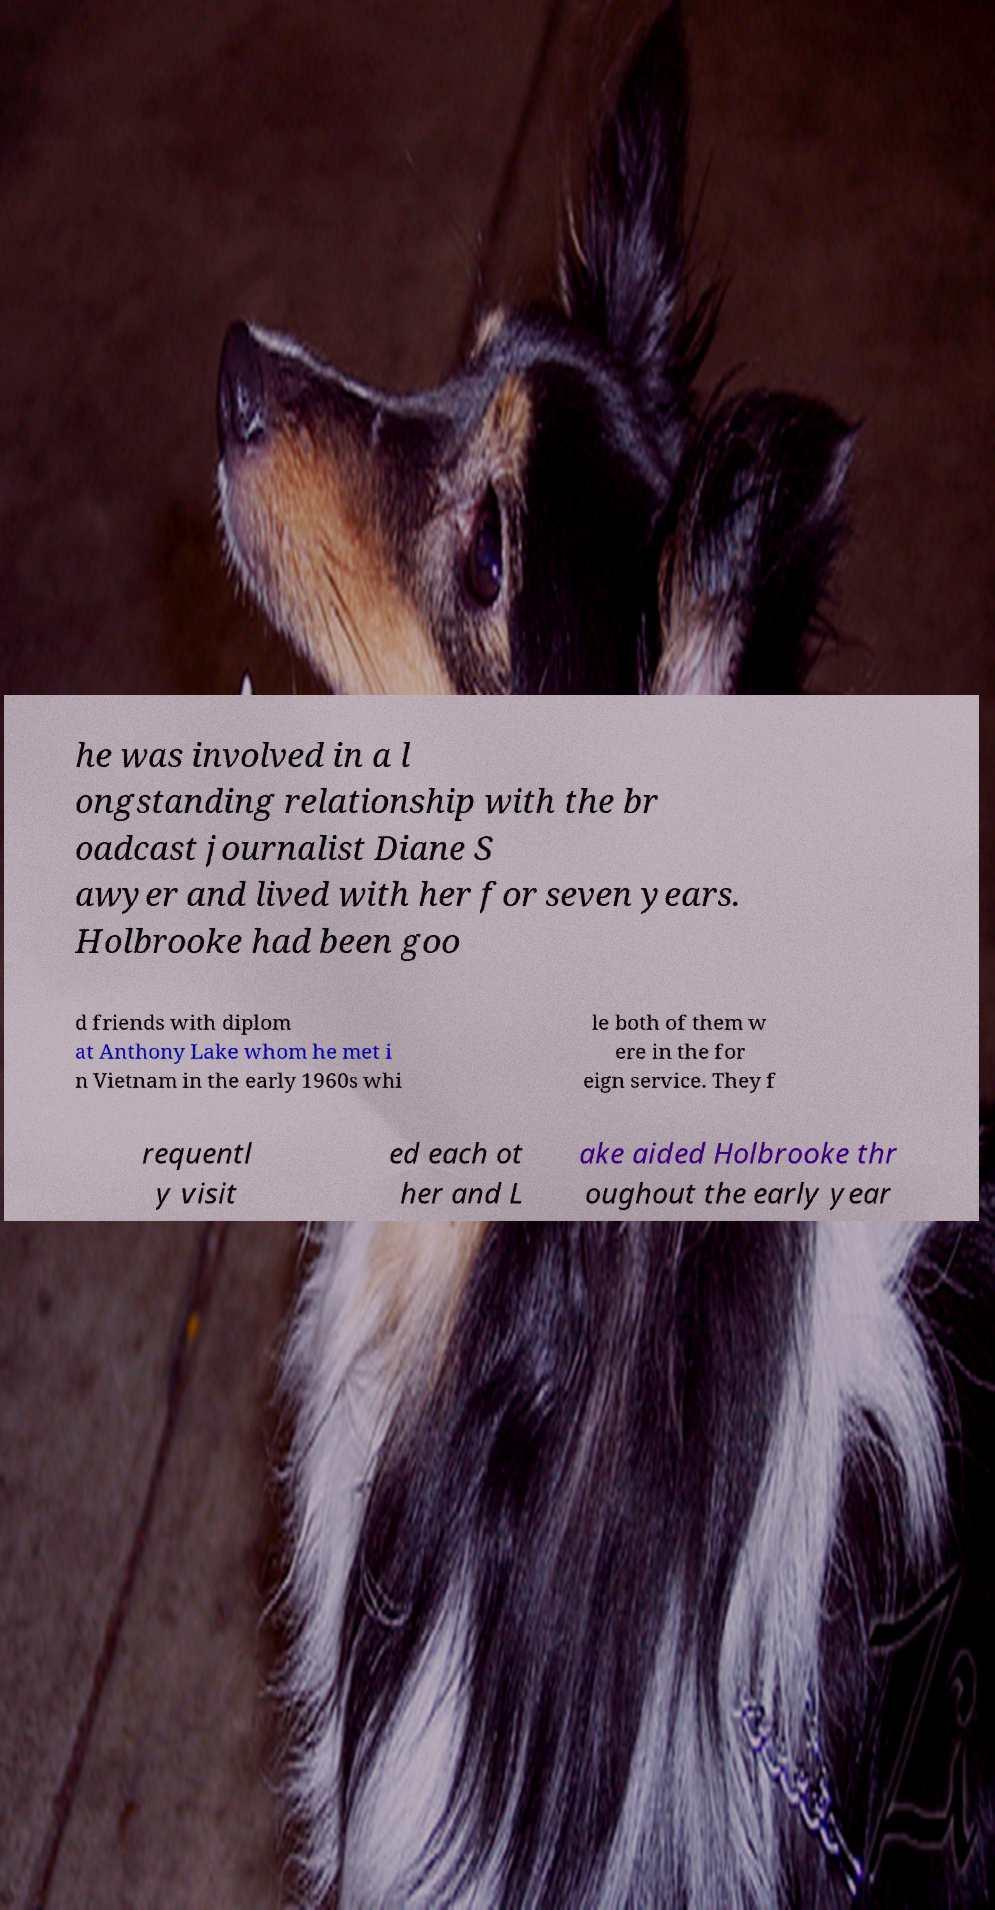I need the written content from this picture converted into text. Can you do that? he was involved in a l ongstanding relationship with the br oadcast journalist Diane S awyer and lived with her for seven years. Holbrooke had been goo d friends with diplom at Anthony Lake whom he met i n Vietnam in the early 1960s whi le both of them w ere in the for eign service. They f requentl y visit ed each ot her and L ake aided Holbrooke thr oughout the early year 